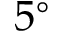<formula> <loc_0><loc_0><loc_500><loc_500>5 ^ { \circ }</formula> 